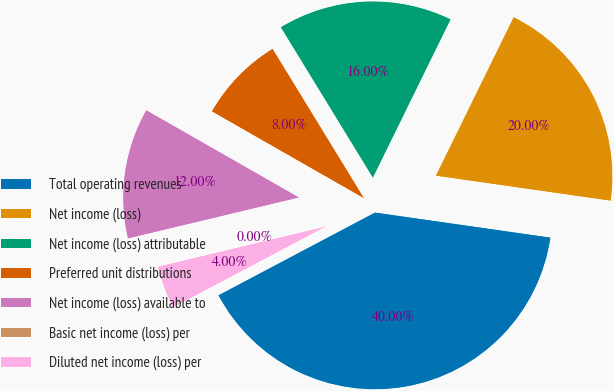Convert chart to OTSL. <chart><loc_0><loc_0><loc_500><loc_500><pie_chart><fcel>Total operating revenues<fcel>Net income (loss)<fcel>Net income (loss) attributable<fcel>Preferred unit distributions<fcel>Net income (loss) available to<fcel>Basic net income (loss) per<fcel>Diluted net income (loss) per<nl><fcel>40.0%<fcel>20.0%<fcel>16.0%<fcel>8.0%<fcel>12.0%<fcel>0.0%<fcel>4.0%<nl></chart> 